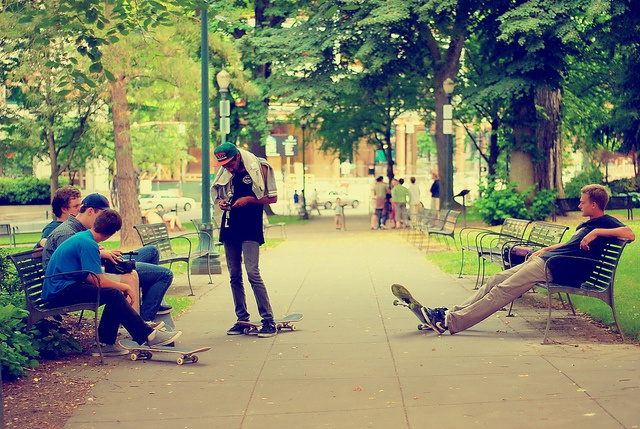Describe the objects in this image and their specific colors. I can see people in tan, navy, and gray tones, people in tan, navy, blue, darkblue, and purple tones, people in tan, navy, gray, purple, and khaki tones, bench in tan, navy, purple, gray, and blue tones, and bench in tan, navy, gray, and purple tones in this image. 